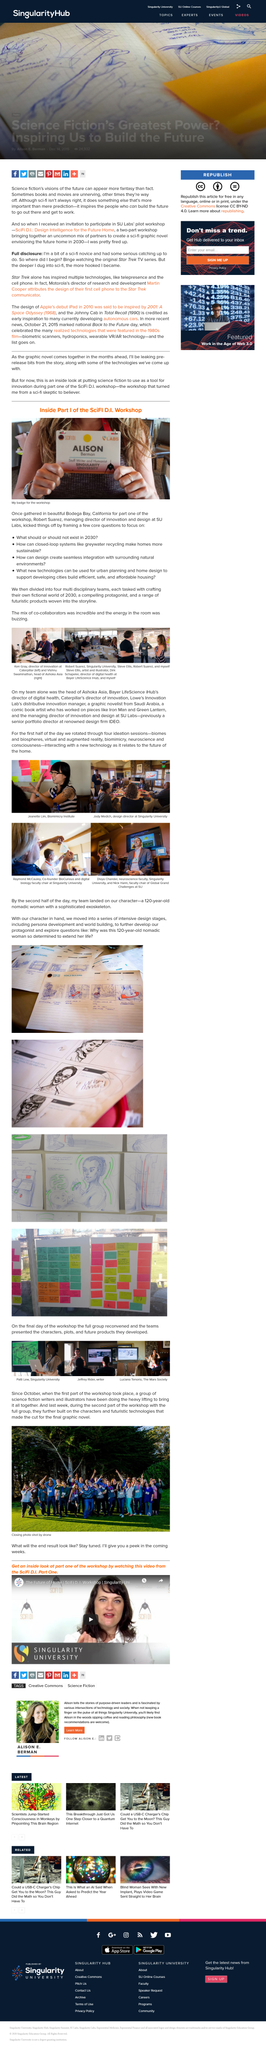Give some essential details in this illustration. The first photograph depicts Ken Gray and Vishnu Swaminathan. The workshop was held in Bodega Bay, California. Ken Gray is the Director of Innovation at Caterpillar, and that is his title. The photograph was taken at the second workshop. The first workshop was not the location of the photograph. The closing group photo was taken using a drone, which is a type of technology. 